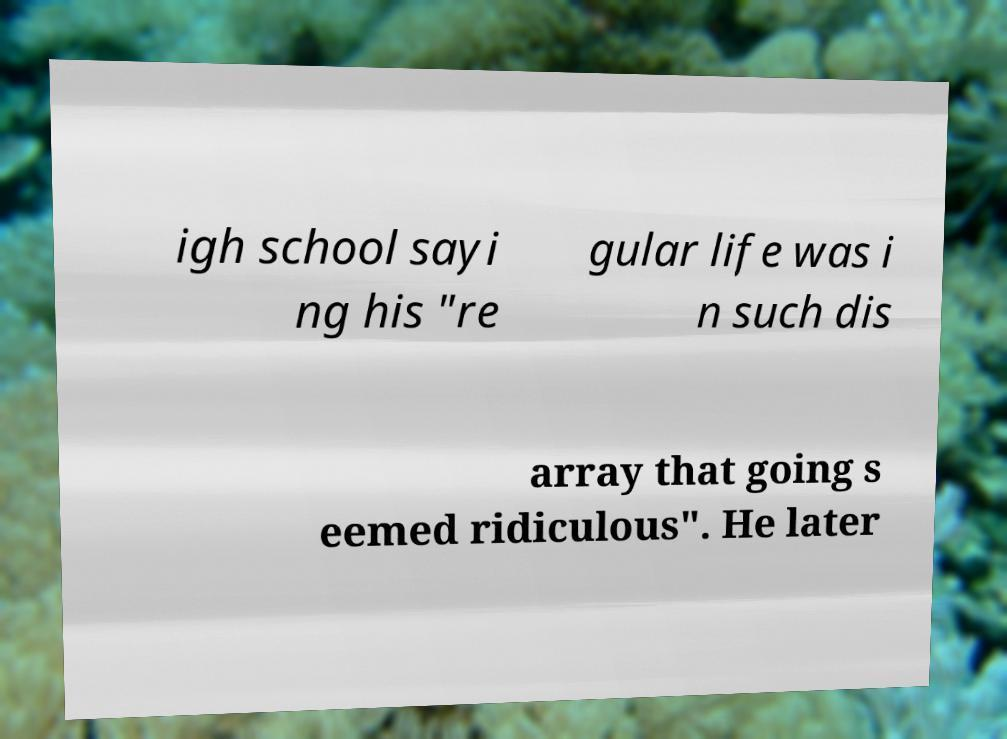Can you read and provide the text displayed in the image?This photo seems to have some interesting text. Can you extract and type it out for me? igh school sayi ng his "re gular life was i n such dis array that going s eemed ridiculous". He later 